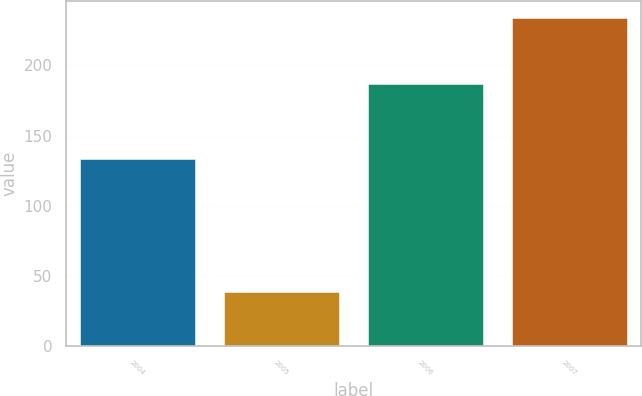Convert chart to OTSL. <chart><loc_0><loc_0><loc_500><loc_500><bar_chart><fcel>2004<fcel>2005<fcel>2006<fcel>2007<nl><fcel>133<fcel>39<fcel>187<fcel>234<nl></chart> 